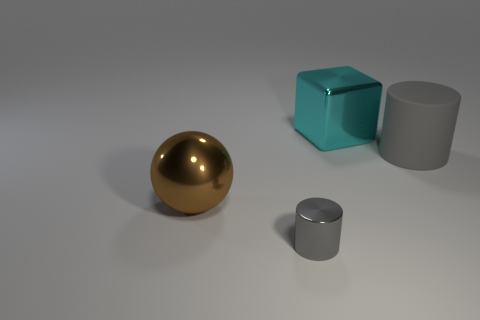There is a metal object that is in front of the brown object; does it have the same shape as the big gray matte object?
Provide a short and direct response. Yes. There is another big gray thing that is the same shape as the gray metallic object; what is it made of?
Your answer should be very brief. Rubber. Is there anything else that has the same size as the metallic cylinder?
Provide a short and direct response. No. Is there a brown matte sphere?
Ensure brevity in your answer.  No. What is the material of the gray thing that is on the right side of the large cyan shiny object right of the shiny thing to the left of the tiny metallic object?
Ensure brevity in your answer.  Rubber. Is the shape of the tiny gray object the same as the big object that is on the right side of the cube?
Ensure brevity in your answer.  Yes. How many other things have the same shape as the large rubber thing?
Provide a succinct answer. 1. The brown metal thing has what shape?
Your answer should be very brief. Sphere. There is a gray thing to the right of the cylinder that is on the left side of the block; what is its size?
Give a very brief answer. Large. How many things are gray rubber things or tiny gray metal things?
Your response must be concise. 2. 